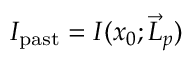Convert formula to latex. <formula><loc_0><loc_0><loc_500><loc_500>I _ { p a s t } = I ( x _ { 0 } ; { \vec { L } } _ { p } )</formula> 